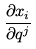Convert formula to latex. <formula><loc_0><loc_0><loc_500><loc_500>\frac { \partial x _ { i } } { \partial q ^ { j } }</formula> 